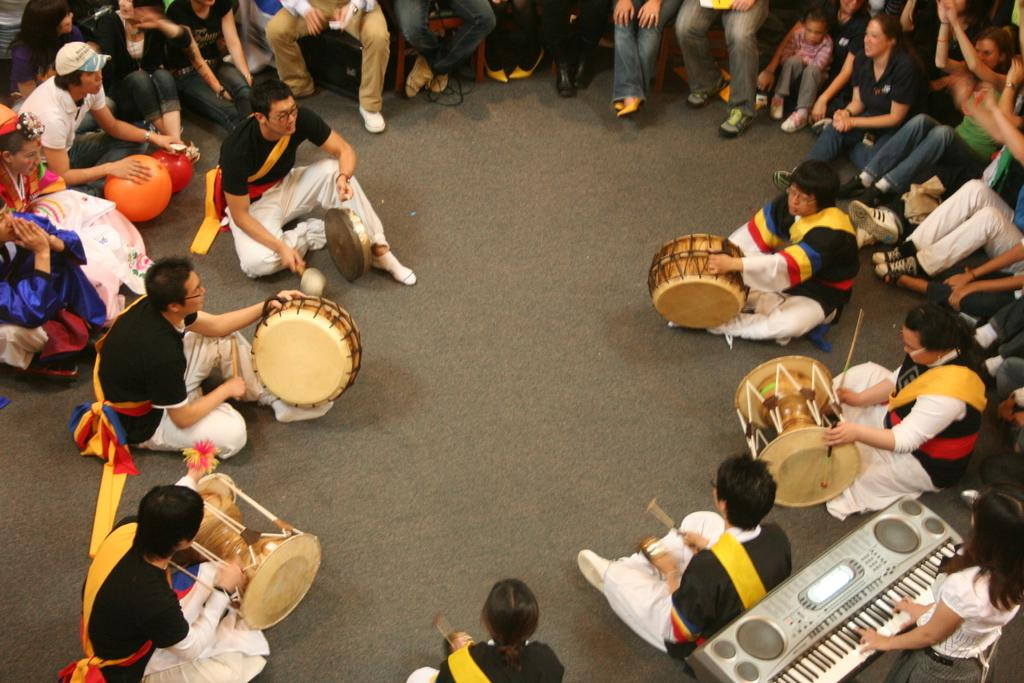What are the people in the image doing? The persons in the image are sitting on the road and playing musical instruments. Can you identify any specific musical instruments being played? Yes, there is a woman playing the piano. What type of bun is being used as a drumstick in the image? There is no bun or drumstick present in the image; the people are playing musical instruments like the piano. 